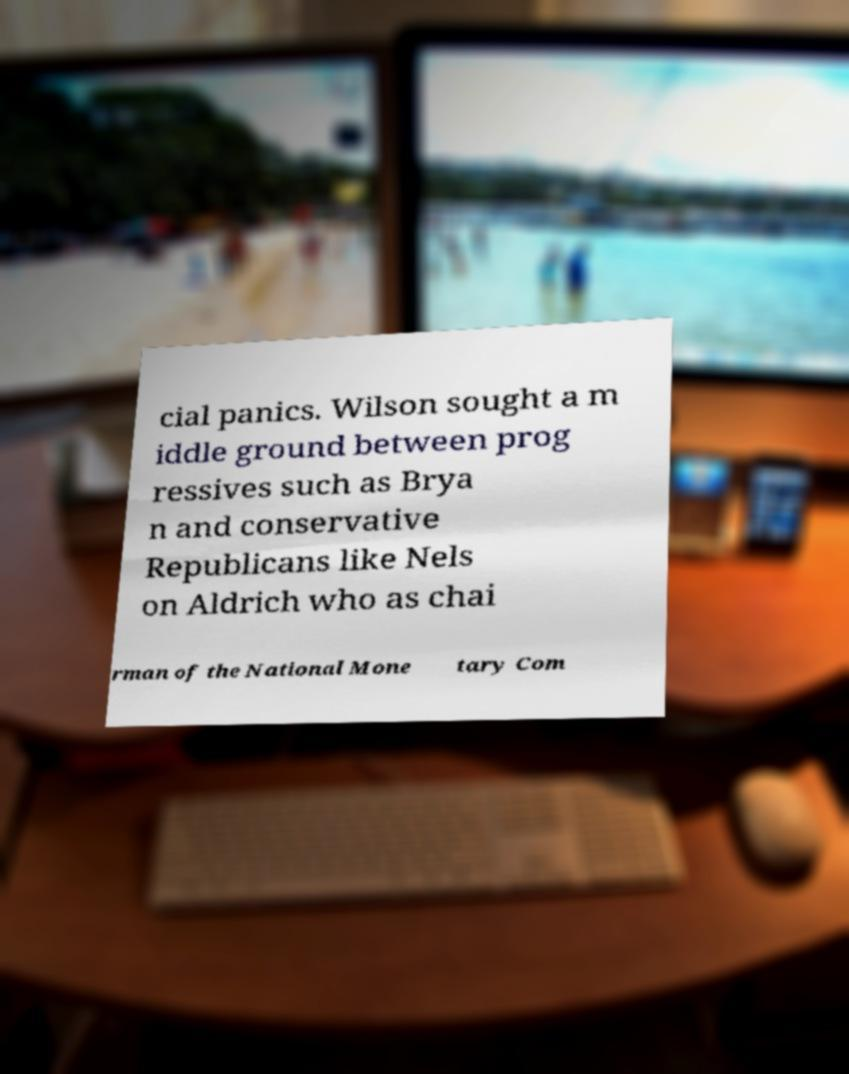Can you accurately transcribe the text from the provided image for me? cial panics. Wilson sought a m iddle ground between prog ressives such as Brya n and conservative Republicans like Nels on Aldrich who as chai rman of the National Mone tary Com 